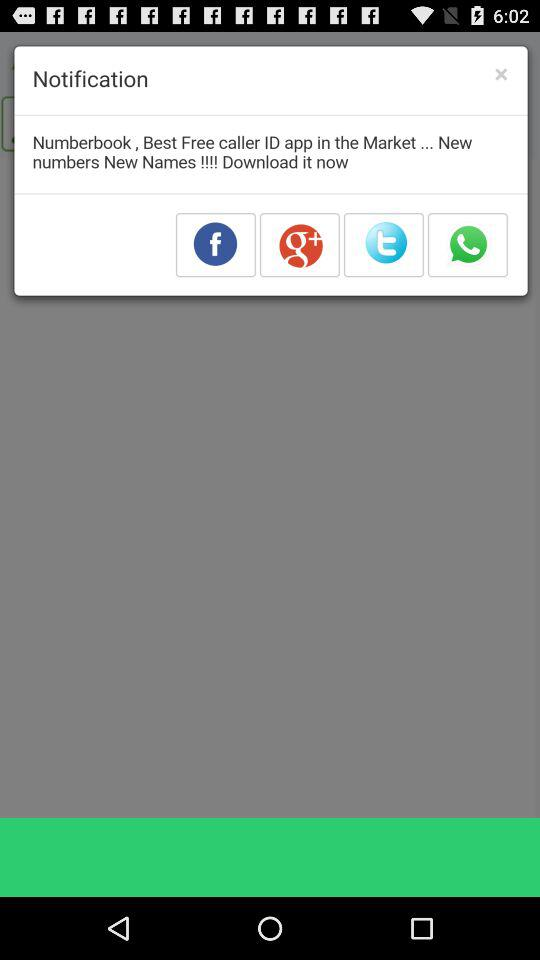What are the different sharing options? The different sharing options are "Facebook", "Google+", "Twitter" and "WhatsApp". 